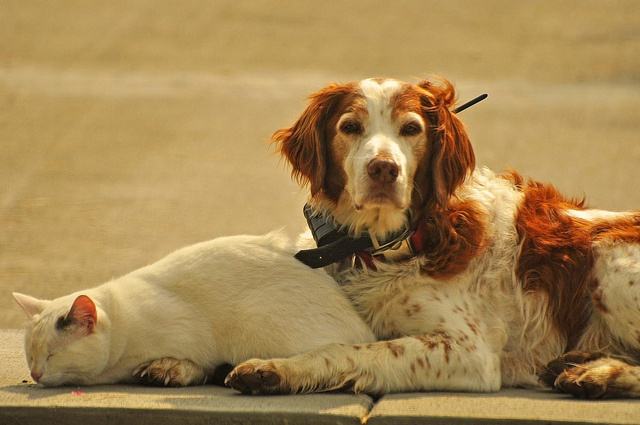Describe the objects in this image and their specific colors. I can see dog in tan, brown, maroon, and black tones and cat in tan and olive tones in this image. 